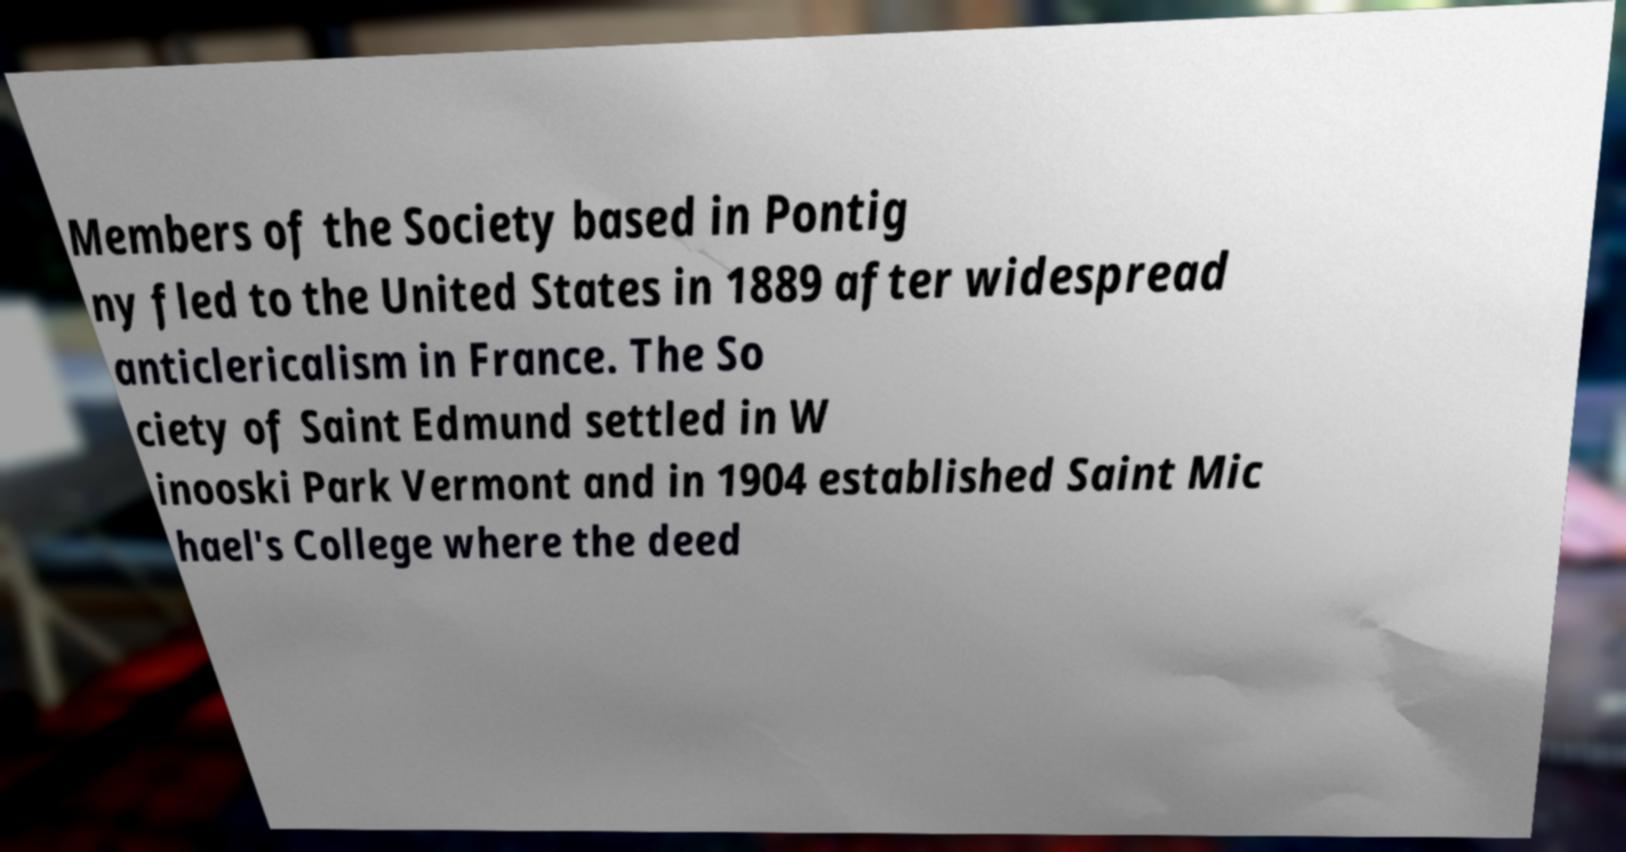Please identify and transcribe the text found in this image. Members of the Society based in Pontig ny fled to the United States in 1889 after widespread anticlericalism in France. The So ciety of Saint Edmund settled in W inooski Park Vermont and in 1904 established Saint Mic hael's College where the deed 